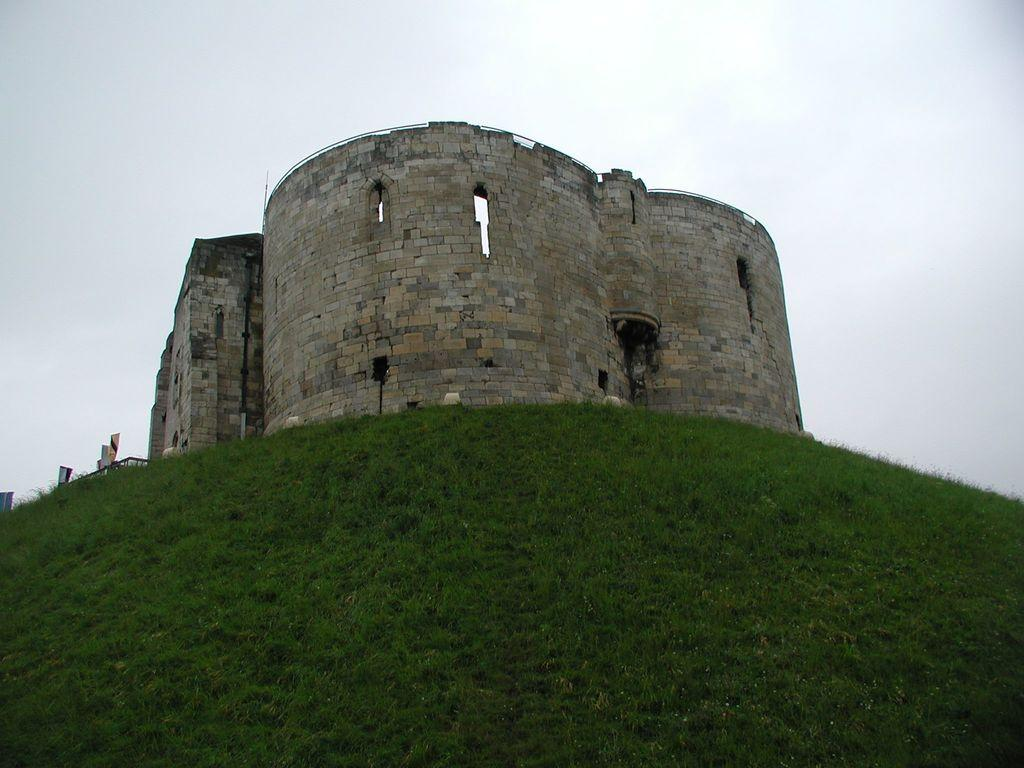What type of structure is located on the mountain in the image? There is a big fort on a mountain in the image. What type of vegetation can be seen on the surface in the image? There is green grass on the surface in the image. What are the poles used for in the image? The purpose of the poles is not specified in the image, but they are visible. What objects can be seen on the surface in the image? There are objects on the surface in the image, but their specific nature is not mentioned in the facts. What is visible at the top of the image? The sky is visible at the top of the image. How many cars are parked near the fort in the image? There is no mention of cars in the image, so we cannot determine the number of cars present. 